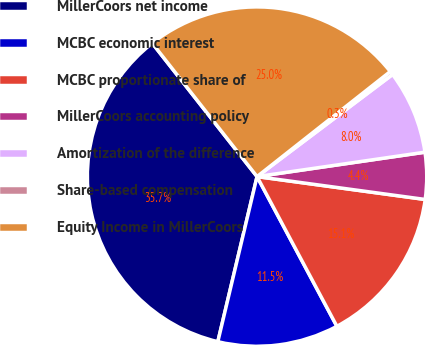<chart> <loc_0><loc_0><loc_500><loc_500><pie_chart><fcel>MillerCoors net income<fcel>MCBC economic interest<fcel>MCBC proportionate share of<fcel>MillerCoors accounting policy<fcel>Amortization of the difference<fcel>Share-based compensation<fcel>Equity Income in MillerCoors<nl><fcel>35.69%<fcel>11.51%<fcel>15.05%<fcel>4.45%<fcel>7.98%<fcel>0.35%<fcel>24.97%<nl></chart> 